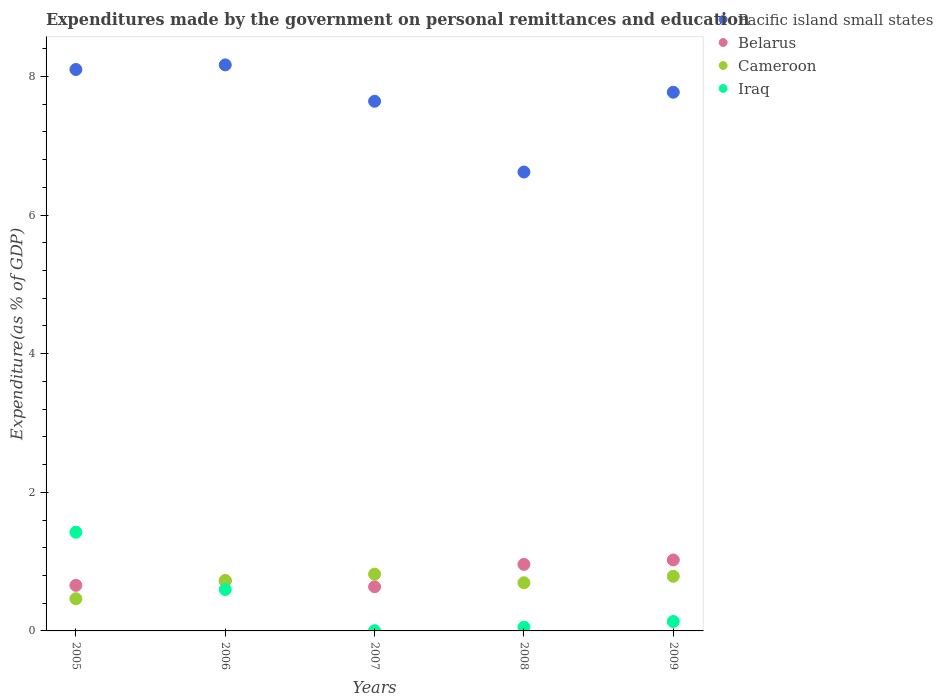Is the number of dotlines equal to the number of legend labels?
Ensure brevity in your answer.  Yes. What is the expenditures made by the government on personal remittances and education in Pacific island small states in 2007?
Your answer should be very brief. 7.64. Across all years, what is the maximum expenditures made by the government on personal remittances and education in Iraq?
Your answer should be compact. 1.42. Across all years, what is the minimum expenditures made by the government on personal remittances and education in Cameroon?
Offer a terse response. 0.46. What is the total expenditures made by the government on personal remittances and education in Pacific island small states in the graph?
Your answer should be compact. 38.3. What is the difference between the expenditures made by the government on personal remittances and education in Pacific island small states in 2005 and that in 2009?
Provide a short and direct response. 0.33. What is the difference between the expenditures made by the government on personal remittances and education in Iraq in 2006 and the expenditures made by the government on personal remittances and education in Cameroon in 2009?
Offer a terse response. -0.19. What is the average expenditures made by the government on personal remittances and education in Cameroon per year?
Provide a short and direct response. 0.7. In the year 2007, what is the difference between the expenditures made by the government on personal remittances and education in Cameroon and expenditures made by the government on personal remittances and education in Pacific island small states?
Give a very brief answer. -6.82. In how many years, is the expenditures made by the government on personal remittances and education in Iraq greater than 7.6 %?
Your response must be concise. 0. What is the ratio of the expenditures made by the government on personal remittances and education in Cameroon in 2006 to that in 2009?
Offer a terse response. 0.92. Is the expenditures made by the government on personal remittances and education in Cameroon in 2005 less than that in 2009?
Your answer should be very brief. Yes. Is the difference between the expenditures made by the government on personal remittances and education in Cameroon in 2005 and 2008 greater than the difference between the expenditures made by the government on personal remittances and education in Pacific island small states in 2005 and 2008?
Make the answer very short. No. What is the difference between the highest and the second highest expenditures made by the government on personal remittances and education in Cameroon?
Provide a short and direct response. 0.03. What is the difference between the highest and the lowest expenditures made by the government on personal remittances and education in Cameroon?
Give a very brief answer. 0.35. Is the sum of the expenditures made by the government on personal remittances and education in Cameroon in 2006 and 2009 greater than the maximum expenditures made by the government on personal remittances and education in Iraq across all years?
Your answer should be compact. Yes. Is it the case that in every year, the sum of the expenditures made by the government on personal remittances and education in Belarus and expenditures made by the government on personal remittances and education in Pacific island small states  is greater than the sum of expenditures made by the government on personal remittances and education in Iraq and expenditures made by the government on personal remittances and education in Cameroon?
Provide a short and direct response. No. Is the expenditures made by the government on personal remittances and education in Iraq strictly greater than the expenditures made by the government on personal remittances and education in Cameroon over the years?
Provide a succinct answer. No. How many dotlines are there?
Make the answer very short. 4. Does the graph contain any zero values?
Give a very brief answer. No. Does the graph contain grids?
Your response must be concise. No. Where does the legend appear in the graph?
Ensure brevity in your answer.  Top right. How are the legend labels stacked?
Give a very brief answer. Vertical. What is the title of the graph?
Give a very brief answer. Expenditures made by the government on personal remittances and education. What is the label or title of the X-axis?
Make the answer very short. Years. What is the label or title of the Y-axis?
Your answer should be compact. Expenditure(as % of GDP). What is the Expenditure(as % of GDP) of Pacific island small states in 2005?
Your response must be concise. 8.1. What is the Expenditure(as % of GDP) of Belarus in 2005?
Keep it short and to the point. 0.66. What is the Expenditure(as % of GDP) in Cameroon in 2005?
Provide a succinct answer. 0.46. What is the Expenditure(as % of GDP) in Iraq in 2005?
Give a very brief answer. 1.42. What is the Expenditure(as % of GDP) in Pacific island small states in 2006?
Your answer should be compact. 8.17. What is the Expenditure(as % of GDP) of Belarus in 2006?
Offer a terse response. 0.73. What is the Expenditure(as % of GDP) in Cameroon in 2006?
Provide a succinct answer. 0.72. What is the Expenditure(as % of GDP) of Iraq in 2006?
Ensure brevity in your answer.  0.6. What is the Expenditure(as % of GDP) in Pacific island small states in 2007?
Keep it short and to the point. 7.64. What is the Expenditure(as % of GDP) of Belarus in 2007?
Offer a very short reply. 0.64. What is the Expenditure(as % of GDP) in Cameroon in 2007?
Provide a short and direct response. 0.82. What is the Expenditure(as % of GDP) of Iraq in 2007?
Make the answer very short. 0. What is the Expenditure(as % of GDP) of Pacific island small states in 2008?
Provide a succinct answer. 6.62. What is the Expenditure(as % of GDP) in Belarus in 2008?
Your response must be concise. 0.96. What is the Expenditure(as % of GDP) in Cameroon in 2008?
Keep it short and to the point. 0.69. What is the Expenditure(as % of GDP) of Iraq in 2008?
Provide a short and direct response. 0.05. What is the Expenditure(as % of GDP) in Pacific island small states in 2009?
Your answer should be very brief. 7.77. What is the Expenditure(as % of GDP) of Belarus in 2009?
Provide a succinct answer. 1.02. What is the Expenditure(as % of GDP) of Cameroon in 2009?
Offer a terse response. 0.79. What is the Expenditure(as % of GDP) in Iraq in 2009?
Provide a short and direct response. 0.14. Across all years, what is the maximum Expenditure(as % of GDP) of Pacific island small states?
Your response must be concise. 8.17. Across all years, what is the maximum Expenditure(as % of GDP) of Belarus?
Provide a short and direct response. 1.02. Across all years, what is the maximum Expenditure(as % of GDP) in Cameroon?
Your answer should be compact. 0.82. Across all years, what is the maximum Expenditure(as % of GDP) in Iraq?
Offer a terse response. 1.42. Across all years, what is the minimum Expenditure(as % of GDP) in Pacific island small states?
Provide a short and direct response. 6.62. Across all years, what is the minimum Expenditure(as % of GDP) of Belarus?
Your answer should be very brief. 0.64. Across all years, what is the minimum Expenditure(as % of GDP) of Cameroon?
Offer a very short reply. 0.46. Across all years, what is the minimum Expenditure(as % of GDP) in Iraq?
Make the answer very short. 0. What is the total Expenditure(as % of GDP) in Pacific island small states in the graph?
Give a very brief answer. 38.3. What is the total Expenditure(as % of GDP) of Belarus in the graph?
Offer a very short reply. 4. What is the total Expenditure(as % of GDP) in Cameroon in the graph?
Offer a very short reply. 3.49. What is the total Expenditure(as % of GDP) in Iraq in the graph?
Make the answer very short. 2.21. What is the difference between the Expenditure(as % of GDP) in Pacific island small states in 2005 and that in 2006?
Offer a very short reply. -0.07. What is the difference between the Expenditure(as % of GDP) of Belarus in 2005 and that in 2006?
Give a very brief answer. -0.07. What is the difference between the Expenditure(as % of GDP) in Cameroon in 2005 and that in 2006?
Your response must be concise. -0.26. What is the difference between the Expenditure(as % of GDP) of Iraq in 2005 and that in 2006?
Give a very brief answer. 0.83. What is the difference between the Expenditure(as % of GDP) of Pacific island small states in 2005 and that in 2007?
Your answer should be very brief. 0.46. What is the difference between the Expenditure(as % of GDP) in Belarus in 2005 and that in 2007?
Ensure brevity in your answer.  0.02. What is the difference between the Expenditure(as % of GDP) of Cameroon in 2005 and that in 2007?
Make the answer very short. -0.35. What is the difference between the Expenditure(as % of GDP) in Iraq in 2005 and that in 2007?
Ensure brevity in your answer.  1.42. What is the difference between the Expenditure(as % of GDP) of Pacific island small states in 2005 and that in 2008?
Ensure brevity in your answer.  1.48. What is the difference between the Expenditure(as % of GDP) of Belarus in 2005 and that in 2008?
Make the answer very short. -0.3. What is the difference between the Expenditure(as % of GDP) of Cameroon in 2005 and that in 2008?
Make the answer very short. -0.23. What is the difference between the Expenditure(as % of GDP) in Iraq in 2005 and that in 2008?
Keep it short and to the point. 1.37. What is the difference between the Expenditure(as % of GDP) of Pacific island small states in 2005 and that in 2009?
Your answer should be very brief. 0.33. What is the difference between the Expenditure(as % of GDP) in Belarus in 2005 and that in 2009?
Offer a terse response. -0.37. What is the difference between the Expenditure(as % of GDP) of Cameroon in 2005 and that in 2009?
Provide a succinct answer. -0.32. What is the difference between the Expenditure(as % of GDP) in Iraq in 2005 and that in 2009?
Your answer should be very brief. 1.29. What is the difference between the Expenditure(as % of GDP) of Pacific island small states in 2006 and that in 2007?
Your response must be concise. 0.53. What is the difference between the Expenditure(as % of GDP) of Belarus in 2006 and that in 2007?
Offer a very short reply. 0.09. What is the difference between the Expenditure(as % of GDP) in Cameroon in 2006 and that in 2007?
Offer a terse response. -0.1. What is the difference between the Expenditure(as % of GDP) of Iraq in 2006 and that in 2007?
Offer a terse response. 0.59. What is the difference between the Expenditure(as % of GDP) in Pacific island small states in 2006 and that in 2008?
Offer a terse response. 1.55. What is the difference between the Expenditure(as % of GDP) in Belarus in 2006 and that in 2008?
Provide a short and direct response. -0.23. What is the difference between the Expenditure(as % of GDP) of Cameroon in 2006 and that in 2008?
Give a very brief answer. 0.03. What is the difference between the Expenditure(as % of GDP) in Iraq in 2006 and that in 2008?
Ensure brevity in your answer.  0.54. What is the difference between the Expenditure(as % of GDP) of Pacific island small states in 2006 and that in 2009?
Give a very brief answer. 0.4. What is the difference between the Expenditure(as % of GDP) of Belarus in 2006 and that in 2009?
Your response must be concise. -0.3. What is the difference between the Expenditure(as % of GDP) in Cameroon in 2006 and that in 2009?
Your answer should be compact. -0.06. What is the difference between the Expenditure(as % of GDP) of Iraq in 2006 and that in 2009?
Your response must be concise. 0.46. What is the difference between the Expenditure(as % of GDP) of Pacific island small states in 2007 and that in 2008?
Your answer should be compact. 1.02. What is the difference between the Expenditure(as % of GDP) of Belarus in 2007 and that in 2008?
Provide a short and direct response. -0.32. What is the difference between the Expenditure(as % of GDP) of Cameroon in 2007 and that in 2008?
Make the answer very short. 0.12. What is the difference between the Expenditure(as % of GDP) in Iraq in 2007 and that in 2008?
Offer a terse response. -0.05. What is the difference between the Expenditure(as % of GDP) of Pacific island small states in 2007 and that in 2009?
Give a very brief answer. -0.13. What is the difference between the Expenditure(as % of GDP) of Belarus in 2007 and that in 2009?
Offer a very short reply. -0.39. What is the difference between the Expenditure(as % of GDP) of Cameroon in 2007 and that in 2009?
Your answer should be very brief. 0.03. What is the difference between the Expenditure(as % of GDP) in Iraq in 2007 and that in 2009?
Provide a succinct answer. -0.13. What is the difference between the Expenditure(as % of GDP) of Pacific island small states in 2008 and that in 2009?
Ensure brevity in your answer.  -1.15. What is the difference between the Expenditure(as % of GDP) of Belarus in 2008 and that in 2009?
Provide a short and direct response. -0.06. What is the difference between the Expenditure(as % of GDP) of Cameroon in 2008 and that in 2009?
Keep it short and to the point. -0.09. What is the difference between the Expenditure(as % of GDP) of Iraq in 2008 and that in 2009?
Ensure brevity in your answer.  -0.08. What is the difference between the Expenditure(as % of GDP) of Pacific island small states in 2005 and the Expenditure(as % of GDP) of Belarus in 2006?
Your answer should be very brief. 7.37. What is the difference between the Expenditure(as % of GDP) in Pacific island small states in 2005 and the Expenditure(as % of GDP) in Cameroon in 2006?
Provide a succinct answer. 7.38. What is the difference between the Expenditure(as % of GDP) of Pacific island small states in 2005 and the Expenditure(as % of GDP) of Iraq in 2006?
Offer a very short reply. 7.5. What is the difference between the Expenditure(as % of GDP) of Belarus in 2005 and the Expenditure(as % of GDP) of Cameroon in 2006?
Offer a terse response. -0.07. What is the difference between the Expenditure(as % of GDP) in Belarus in 2005 and the Expenditure(as % of GDP) in Iraq in 2006?
Make the answer very short. 0.06. What is the difference between the Expenditure(as % of GDP) of Cameroon in 2005 and the Expenditure(as % of GDP) of Iraq in 2006?
Provide a short and direct response. -0.13. What is the difference between the Expenditure(as % of GDP) in Pacific island small states in 2005 and the Expenditure(as % of GDP) in Belarus in 2007?
Ensure brevity in your answer.  7.46. What is the difference between the Expenditure(as % of GDP) of Pacific island small states in 2005 and the Expenditure(as % of GDP) of Cameroon in 2007?
Your answer should be very brief. 7.28. What is the difference between the Expenditure(as % of GDP) of Pacific island small states in 2005 and the Expenditure(as % of GDP) of Iraq in 2007?
Provide a short and direct response. 8.1. What is the difference between the Expenditure(as % of GDP) of Belarus in 2005 and the Expenditure(as % of GDP) of Cameroon in 2007?
Offer a terse response. -0.16. What is the difference between the Expenditure(as % of GDP) in Belarus in 2005 and the Expenditure(as % of GDP) in Iraq in 2007?
Keep it short and to the point. 0.65. What is the difference between the Expenditure(as % of GDP) of Cameroon in 2005 and the Expenditure(as % of GDP) of Iraq in 2007?
Make the answer very short. 0.46. What is the difference between the Expenditure(as % of GDP) of Pacific island small states in 2005 and the Expenditure(as % of GDP) of Belarus in 2008?
Provide a short and direct response. 7.14. What is the difference between the Expenditure(as % of GDP) in Pacific island small states in 2005 and the Expenditure(as % of GDP) in Cameroon in 2008?
Your answer should be compact. 7.41. What is the difference between the Expenditure(as % of GDP) in Pacific island small states in 2005 and the Expenditure(as % of GDP) in Iraq in 2008?
Keep it short and to the point. 8.05. What is the difference between the Expenditure(as % of GDP) in Belarus in 2005 and the Expenditure(as % of GDP) in Cameroon in 2008?
Your answer should be compact. -0.04. What is the difference between the Expenditure(as % of GDP) in Belarus in 2005 and the Expenditure(as % of GDP) in Iraq in 2008?
Keep it short and to the point. 0.6. What is the difference between the Expenditure(as % of GDP) in Cameroon in 2005 and the Expenditure(as % of GDP) in Iraq in 2008?
Keep it short and to the point. 0.41. What is the difference between the Expenditure(as % of GDP) in Pacific island small states in 2005 and the Expenditure(as % of GDP) in Belarus in 2009?
Offer a terse response. 7.08. What is the difference between the Expenditure(as % of GDP) in Pacific island small states in 2005 and the Expenditure(as % of GDP) in Cameroon in 2009?
Provide a succinct answer. 7.31. What is the difference between the Expenditure(as % of GDP) of Pacific island small states in 2005 and the Expenditure(as % of GDP) of Iraq in 2009?
Your answer should be very brief. 7.96. What is the difference between the Expenditure(as % of GDP) in Belarus in 2005 and the Expenditure(as % of GDP) in Cameroon in 2009?
Your response must be concise. -0.13. What is the difference between the Expenditure(as % of GDP) in Belarus in 2005 and the Expenditure(as % of GDP) in Iraq in 2009?
Your response must be concise. 0.52. What is the difference between the Expenditure(as % of GDP) of Cameroon in 2005 and the Expenditure(as % of GDP) of Iraq in 2009?
Offer a terse response. 0.33. What is the difference between the Expenditure(as % of GDP) in Pacific island small states in 2006 and the Expenditure(as % of GDP) in Belarus in 2007?
Offer a very short reply. 7.53. What is the difference between the Expenditure(as % of GDP) in Pacific island small states in 2006 and the Expenditure(as % of GDP) in Cameroon in 2007?
Ensure brevity in your answer.  7.35. What is the difference between the Expenditure(as % of GDP) in Pacific island small states in 2006 and the Expenditure(as % of GDP) in Iraq in 2007?
Offer a very short reply. 8.16. What is the difference between the Expenditure(as % of GDP) of Belarus in 2006 and the Expenditure(as % of GDP) of Cameroon in 2007?
Give a very brief answer. -0.09. What is the difference between the Expenditure(as % of GDP) in Belarus in 2006 and the Expenditure(as % of GDP) in Iraq in 2007?
Provide a short and direct response. 0.72. What is the difference between the Expenditure(as % of GDP) in Cameroon in 2006 and the Expenditure(as % of GDP) in Iraq in 2007?
Your answer should be very brief. 0.72. What is the difference between the Expenditure(as % of GDP) of Pacific island small states in 2006 and the Expenditure(as % of GDP) of Belarus in 2008?
Give a very brief answer. 7.21. What is the difference between the Expenditure(as % of GDP) in Pacific island small states in 2006 and the Expenditure(as % of GDP) in Cameroon in 2008?
Offer a terse response. 7.47. What is the difference between the Expenditure(as % of GDP) in Pacific island small states in 2006 and the Expenditure(as % of GDP) in Iraq in 2008?
Your answer should be very brief. 8.11. What is the difference between the Expenditure(as % of GDP) of Belarus in 2006 and the Expenditure(as % of GDP) of Cameroon in 2008?
Your answer should be compact. 0.03. What is the difference between the Expenditure(as % of GDP) of Belarus in 2006 and the Expenditure(as % of GDP) of Iraq in 2008?
Ensure brevity in your answer.  0.67. What is the difference between the Expenditure(as % of GDP) of Cameroon in 2006 and the Expenditure(as % of GDP) of Iraq in 2008?
Offer a very short reply. 0.67. What is the difference between the Expenditure(as % of GDP) in Pacific island small states in 2006 and the Expenditure(as % of GDP) in Belarus in 2009?
Your response must be concise. 7.14. What is the difference between the Expenditure(as % of GDP) in Pacific island small states in 2006 and the Expenditure(as % of GDP) in Cameroon in 2009?
Provide a short and direct response. 7.38. What is the difference between the Expenditure(as % of GDP) of Pacific island small states in 2006 and the Expenditure(as % of GDP) of Iraq in 2009?
Give a very brief answer. 8.03. What is the difference between the Expenditure(as % of GDP) in Belarus in 2006 and the Expenditure(as % of GDP) in Cameroon in 2009?
Your answer should be very brief. -0.06. What is the difference between the Expenditure(as % of GDP) of Belarus in 2006 and the Expenditure(as % of GDP) of Iraq in 2009?
Offer a terse response. 0.59. What is the difference between the Expenditure(as % of GDP) of Cameroon in 2006 and the Expenditure(as % of GDP) of Iraq in 2009?
Your answer should be very brief. 0.59. What is the difference between the Expenditure(as % of GDP) in Pacific island small states in 2007 and the Expenditure(as % of GDP) in Belarus in 2008?
Keep it short and to the point. 6.68. What is the difference between the Expenditure(as % of GDP) in Pacific island small states in 2007 and the Expenditure(as % of GDP) in Cameroon in 2008?
Your answer should be very brief. 6.95. What is the difference between the Expenditure(as % of GDP) in Pacific island small states in 2007 and the Expenditure(as % of GDP) in Iraq in 2008?
Give a very brief answer. 7.59. What is the difference between the Expenditure(as % of GDP) in Belarus in 2007 and the Expenditure(as % of GDP) in Cameroon in 2008?
Your answer should be compact. -0.06. What is the difference between the Expenditure(as % of GDP) in Belarus in 2007 and the Expenditure(as % of GDP) in Iraq in 2008?
Keep it short and to the point. 0.58. What is the difference between the Expenditure(as % of GDP) in Cameroon in 2007 and the Expenditure(as % of GDP) in Iraq in 2008?
Provide a short and direct response. 0.77. What is the difference between the Expenditure(as % of GDP) in Pacific island small states in 2007 and the Expenditure(as % of GDP) in Belarus in 2009?
Provide a succinct answer. 6.62. What is the difference between the Expenditure(as % of GDP) of Pacific island small states in 2007 and the Expenditure(as % of GDP) of Cameroon in 2009?
Ensure brevity in your answer.  6.85. What is the difference between the Expenditure(as % of GDP) in Pacific island small states in 2007 and the Expenditure(as % of GDP) in Iraq in 2009?
Your response must be concise. 7.51. What is the difference between the Expenditure(as % of GDP) in Belarus in 2007 and the Expenditure(as % of GDP) in Cameroon in 2009?
Make the answer very short. -0.15. What is the difference between the Expenditure(as % of GDP) in Belarus in 2007 and the Expenditure(as % of GDP) in Iraq in 2009?
Ensure brevity in your answer.  0.5. What is the difference between the Expenditure(as % of GDP) in Cameroon in 2007 and the Expenditure(as % of GDP) in Iraq in 2009?
Keep it short and to the point. 0.68. What is the difference between the Expenditure(as % of GDP) in Pacific island small states in 2008 and the Expenditure(as % of GDP) in Belarus in 2009?
Give a very brief answer. 5.6. What is the difference between the Expenditure(as % of GDP) in Pacific island small states in 2008 and the Expenditure(as % of GDP) in Cameroon in 2009?
Provide a short and direct response. 5.83. What is the difference between the Expenditure(as % of GDP) in Pacific island small states in 2008 and the Expenditure(as % of GDP) in Iraq in 2009?
Offer a terse response. 6.48. What is the difference between the Expenditure(as % of GDP) of Belarus in 2008 and the Expenditure(as % of GDP) of Cameroon in 2009?
Ensure brevity in your answer.  0.17. What is the difference between the Expenditure(as % of GDP) of Belarus in 2008 and the Expenditure(as % of GDP) of Iraq in 2009?
Your response must be concise. 0.82. What is the difference between the Expenditure(as % of GDP) in Cameroon in 2008 and the Expenditure(as % of GDP) in Iraq in 2009?
Keep it short and to the point. 0.56. What is the average Expenditure(as % of GDP) of Pacific island small states per year?
Make the answer very short. 7.66. What is the average Expenditure(as % of GDP) in Belarus per year?
Make the answer very short. 0.8. What is the average Expenditure(as % of GDP) in Cameroon per year?
Offer a very short reply. 0.7. What is the average Expenditure(as % of GDP) in Iraq per year?
Offer a terse response. 0.44. In the year 2005, what is the difference between the Expenditure(as % of GDP) of Pacific island small states and Expenditure(as % of GDP) of Belarus?
Your answer should be very brief. 7.44. In the year 2005, what is the difference between the Expenditure(as % of GDP) in Pacific island small states and Expenditure(as % of GDP) in Cameroon?
Provide a short and direct response. 7.64. In the year 2005, what is the difference between the Expenditure(as % of GDP) in Pacific island small states and Expenditure(as % of GDP) in Iraq?
Offer a terse response. 6.68. In the year 2005, what is the difference between the Expenditure(as % of GDP) in Belarus and Expenditure(as % of GDP) in Cameroon?
Offer a terse response. 0.19. In the year 2005, what is the difference between the Expenditure(as % of GDP) in Belarus and Expenditure(as % of GDP) in Iraq?
Make the answer very short. -0.77. In the year 2005, what is the difference between the Expenditure(as % of GDP) in Cameroon and Expenditure(as % of GDP) in Iraq?
Your answer should be very brief. -0.96. In the year 2006, what is the difference between the Expenditure(as % of GDP) in Pacific island small states and Expenditure(as % of GDP) in Belarus?
Your response must be concise. 7.44. In the year 2006, what is the difference between the Expenditure(as % of GDP) in Pacific island small states and Expenditure(as % of GDP) in Cameroon?
Keep it short and to the point. 7.44. In the year 2006, what is the difference between the Expenditure(as % of GDP) of Pacific island small states and Expenditure(as % of GDP) of Iraq?
Give a very brief answer. 7.57. In the year 2006, what is the difference between the Expenditure(as % of GDP) in Belarus and Expenditure(as % of GDP) in Cameroon?
Your answer should be very brief. 0. In the year 2006, what is the difference between the Expenditure(as % of GDP) in Belarus and Expenditure(as % of GDP) in Iraq?
Ensure brevity in your answer.  0.13. In the year 2006, what is the difference between the Expenditure(as % of GDP) in Cameroon and Expenditure(as % of GDP) in Iraq?
Your answer should be compact. 0.13. In the year 2007, what is the difference between the Expenditure(as % of GDP) in Pacific island small states and Expenditure(as % of GDP) in Belarus?
Offer a terse response. 7.01. In the year 2007, what is the difference between the Expenditure(as % of GDP) in Pacific island small states and Expenditure(as % of GDP) in Cameroon?
Your answer should be very brief. 6.82. In the year 2007, what is the difference between the Expenditure(as % of GDP) of Pacific island small states and Expenditure(as % of GDP) of Iraq?
Keep it short and to the point. 7.64. In the year 2007, what is the difference between the Expenditure(as % of GDP) in Belarus and Expenditure(as % of GDP) in Cameroon?
Offer a very short reply. -0.18. In the year 2007, what is the difference between the Expenditure(as % of GDP) in Belarus and Expenditure(as % of GDP) in Iraq?
Offer a terse response. 0.63. In the year 2007, what is the difference between the Expenditure(as % of GDP) in Cameroon and Expenditure(as % of GDP) in Iraq?
Ensure brevity in your answer.  0.82. In the year 2008, what is the difference between the Expenditure(as % of GDP) in Pacific island small states and Expenditure(as % of GDP) in Belarus?
Offer a very short reply. 5.66. In the year 2008, what is the difference between the Expenditure(as % of GDP) in Pacific island small states and Expenditure(as % of GDP) in Cameroon?
Your response must be concise. 5.93. In the year 2008, what is the difference between the Expenditure(as % of GDP) in Pacific island small states and Expenditure(as % of GDP) in Iraq?
Offer a very short reply. 6.57. In the year 2008, what is the difference between the Expenditure(as % of GDP) in Belarus and Expenditure(as % of GDP) in Cameroon?
Keep it short and to the point. 0.27. In the year 2008, what is the difference between the Expenditure(as % of GDP) in Belarus and Expenditure(as % of GDP) in Iraq?
Give a very brief answer. 0.91. In the year 2008, what is the difference between the Expenditure(as % of GDP) of Cameroon and Expenditure(as % of GDP) of Iraq?
Your answer should be compact. 0.64. In the year 2009, what is the difference between the Expenditure(as % of GDP) in Pacific island small states and Expenditure(as % of GDP) in Belarus?
Your answer should be very brief. 6.75. In the year 2009, what is the difference between the Expenditure(as % of GDP) in Pacific island small states and Expenditure(as % of GDP) in Cameroon?
Offer a very short reply. 6.98. In the year 2009, what is the difference between the Expenditure(as % of GDP) in Pacific island small states and Expenditure(as % of GDP) in Iraq?
Give a very brief answer. 7.64. In the year 2009, what is the difference between the Expenditure(as % of GDP) in Belarus and Expenditure(as % of GDP) in Cameroon?
Keep it short and to the point. 0.24. In the year 2009, what is the difference between the Expenditure(as % of GDP) of Belarus and Expenditure(as % of GDP) of Iraq?
Provide a short and direct response. 0.89. In the year 2009, what is the difference between the Expenditure(as % of GDP) of Cameroon and Expenditure(as % of GDP) of Iraq?
Offer a very short reply. 0.65. What is the ratio of the Expenditure(as % of GDP) of Pacific island small states in 2005 to that in 2006?
Provide a succinct answer. 0.99. What is the ratio of the Expenditure(as % of GDP) in Belarus in 2005 to that in 2006?
Offer a very short reply. 0.91. What is the ratio of the Expenditure(as % of GDP) in Cameroon in 2005 to that in 2006?
Provide a short and direct response. 0.64. What is the ratio of the Expenditure(as % of GDP) of Iraq in 2005 to that in 2006?
Your answer should be very brief. 2.38. What is the ratio of the Expenditure(as % of GDP) in Pacific island small states in 2005 to that in 2007?
Keep it short and to the point. 1.06. What is the ratio of the Expenditure(as % of GDP) of Belarus in 2005 to that in 2007?
Keep it short and to the point. 1.03. What is the ratio of the Expenditure(as % of GDP) of Cameroon in 2005 to that in 2007?
Your response must be concise. 0.57. What is the ratio of the Expenditure(as % of GDP) in Iraq in 2005 to that in 2007?
Your answer should be compact. 407.94. What is the ratio of the Expenditure(as % of GDP) of Pacific island small states in 2005 to that in 2008?
Offer a terse response. 1.22. What is the ratio of the Expenditure(as % of GDP) of Belarus in 2005 to that in 2008?
Make the answer very short. 0.68. What is the ratio of the Expenditure(as % of GDP) of Cameroon in 2005 to that in 2008?
Your answer should be compact. 0.67. What is the ratio of the Expenditure(as % of GDP) of Iraq in 2005 to that in 2008?
Offer a very short reply. 26.42. What is the ratio of the Expenditure(as % of GDP) of Pacific island small states in 2005 to that in 2009?
Make the answer very short. 1.04. What is the ratio of the Expenditure(as % of GDP) in Belarus in 2005 to that in 2009?
Offer a terse response. 0.64. What is the ratio of the Expenditure(as % of GDP) in Cameroon in 2005 to that in 2009?
Provide a short and direct response. 0.59. What is the ratio of the Expenditure(as % of GDP) of Iraq in 2005 to that in 2009?
Offer a terse response. 10.46. What is the ratio of the Expenditure(as % of GDP) of Pacific island small states in 2006 to that in 2007?
Your answer should be very brief. 1.07. What is the ratio of the Expenditure(as % of GDP) in Belarus in 2006 to that in 2007?
Make the answer very short. 1.14. What is the ratio of the Expenditure(as % of GDP) in Cameroon in 2006 to that in 2007?
Ensure brevity in your answer.  0.88. What is the ratio of the Expenditure(as % of GDP) of Iraq in 2006 to that in 2007?
Offer a very short reply. 171.09. What is the ratio of the Expenditure(as % of GDP) in Pacific island small states in 2006 to that in 2008?
Your response must be concise. 1.23. What is the ratio of the Expenditure(as % of GDP) in Belarus in 2006 to that in 2008?
Your answer should be compact. 0.76. What is the ratio of the Expenditure(as % of GDP) in Cameroon in 2006 to that in 2008?
Offer a very short reply. 1.04. What is the ratio of the Expenditure(as % of GDP) in Iraq in 2006 to that in 2008?
Give a very brief answer. 11.08. What is the ratio of the Expenditure(as % of GDP) in Pacific island small states in 2006 to that in 2009?
Make the answer very short. 1.05. What is the ratio of the Expenditure(as % of GDP) in Belarus in 2006 to that in 2009?
Make the answer very short. 0.71. What is the ratio of the Expenditure(as % of GDP) of Cameroon in 2006 to that in 2009?
Keep it short and to the point. 0.92. What is the ratio of the Expenditure(as % of GDP) in Iraq in 2006 to that in 2009?
Your response must be concise. 4.39. What is the ratio of the Expenditure(as % of GDP) in Pacific island small states in 2007 to that in 2008?
Provide a succinct answer. 1.15. What is the ratio of the Expenditure(as % of GDP) in Belarus in 2007 to that in 2008?
Keep it short and to the point. 0.66. What is the ratio of the Expenditure(as % of GDP) in Cameroon in 2007 to that in 2008?
Your answer should be compact. 1.18. What is the ratio of the Expenditure(as % of GDP) in Iraq in 2007 to that in 2008?
Make the answer very short. 0.06. What is the ratio of the Expenditure(as % of GDP) of Pacific island small states in 2007 to that in 2009?
Give a very brief answer. 0.98. What is the ratio of the Expenditure(as % of GDP) of Belarus in 2007 to that in 2009?
Your answer should be very brief. 0.62. What is the ratio of the Expenditure(as % of GDP) of Cameroon in 2007 to that in 2009?
Ensure brevity in your answer.  1.04. What is the ratio of the Expenditure(as % of GDP) of Iraq in 2007 to that in 2009?
Keep it short and to the point. 0.03. What is the ratio of the Expenditure(as % of GDP) of Pacific island small states in 2008 to that in 2009?
Keep it short and to the point. 0.85. What is the ratio of the Expenditure(as % of GDP) in Belarus in 2008 to that in 2009?
Provide a succinct answer. 0.94. What is the ratio of the Expenditure(as % of GDP) in Cameroon in 2008 to that in 2009?
Give a very brief answer. 0.88. What is the ratio of the Expenditure(as % of GDP) in Iraq in 2008 to that in 2009?
Offer a very short reply. 0.4. What is the difference between the highest and the second highest Expenditure(as % of GDP) of Pacific island small states?
Keep it short and to the point. 0.07. What is the difference between the highest and the second highest Expenditure(as % of GDP) of Belarus?
Make the answer very short. 0.06. What is the difference between the highest and the second highest Expenditure(as % of GDP) in Cameroon?
Ensure brevity in your answer.  0.03. What is the difference between the highest and the second highest Expenditure(as % of GDP) in Iraq?
Your response must be concise. 0.83. What is the difference between the highest and the lowest Expenditure(as % of GDP) in Pacific island small states?
Make the answer very short. 1.55. What is the difference between the highest and the lowest Expenditure(as % of GDP) in Belarus?
Your answer should be compact. 0.39. What is the difference between the highest and the lowest Expenditure(as % of GDP) in Cameroon?
Offer a very short reply. 0.35. What is the difference between the highest and the lowest Expenditure(as % of GDP) of Iraq?
Ensure brevity in your answer.  1.42. 